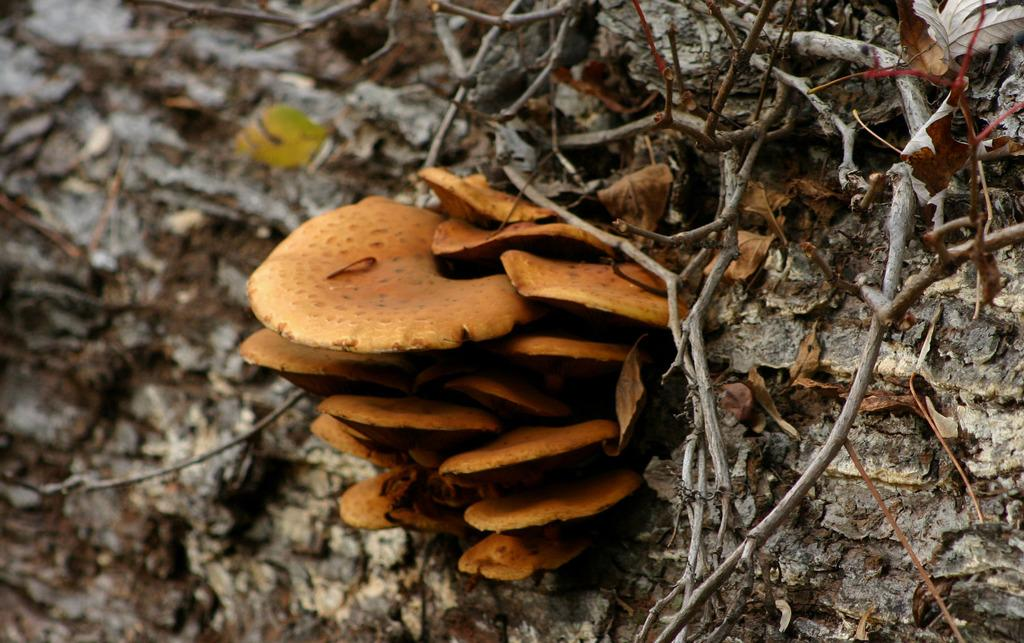What type of natural objects can be seen in the image? There are mushrooms, sticks, and dried leaves in the image. Where are these objects located? These objects are on a tree trunk. What type of building can be seen in the image? There is no building present in the image; it features natural objects on a tree trunk. What color is the skirt in the image? There is no skirt present in the image. 